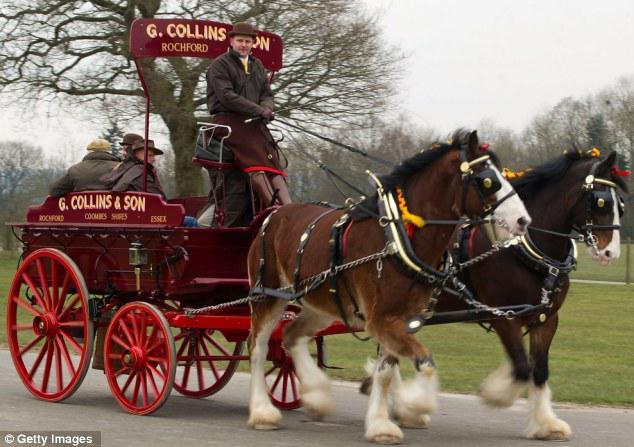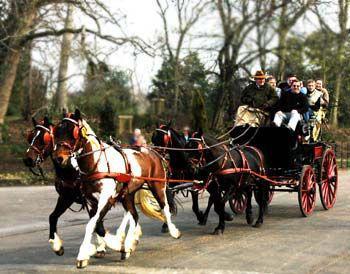The first image is the image on the left, the second image is the image on the right. Analyze the images presented: Is the assertion "An image shows a cart pulled by two Clydesdale horses only." valid? Answer yes or no. Yes. 